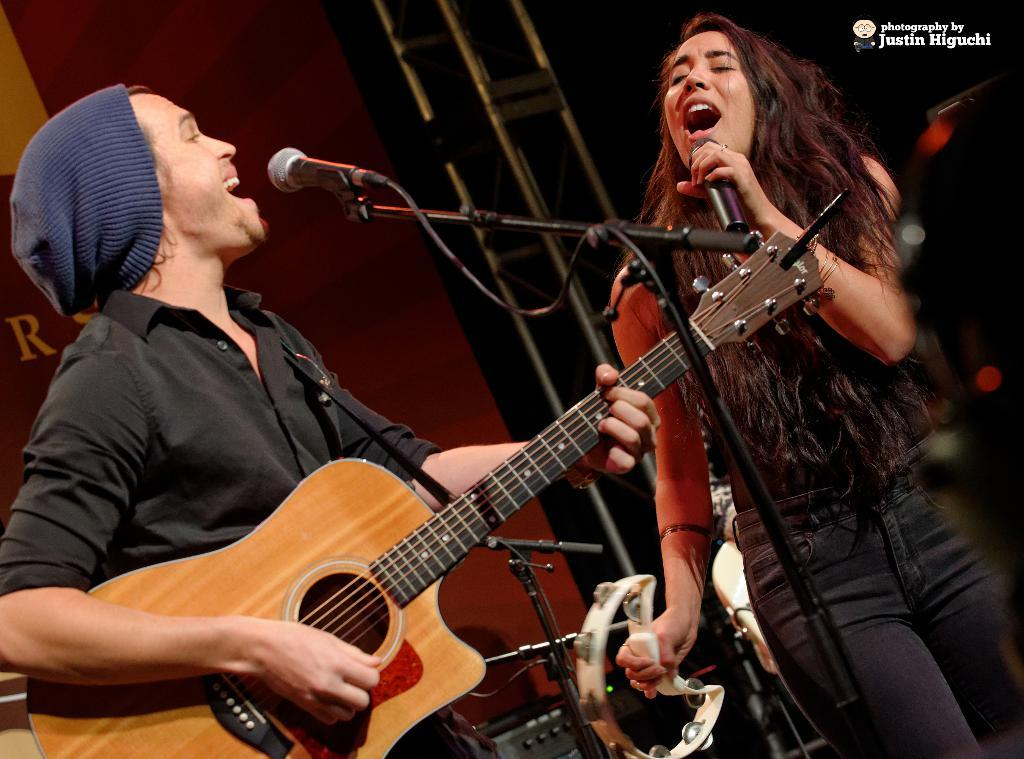What is the man in the image doing? The man is playing a guitar and holding a mic. What is the woman in the image doing? The woman is singing and holding a mic. What can be seen in the background of the image? There is a wall and a pole in the background of the image. What type of blood is visible on the guitar in the image? There is no blood visible on the guitar or any other part of the image. What tool is the man using to play the guitar in the image? The man is using his hands to play the guitar, not a wrench or any other tool. 